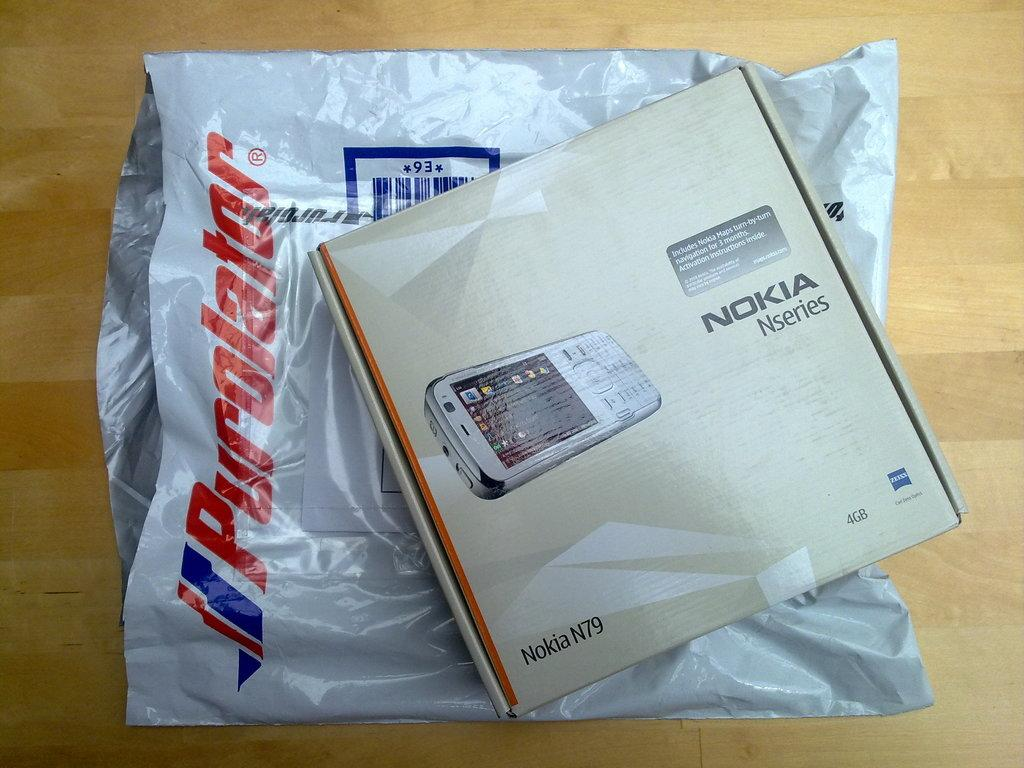<image>
Present a compact description of the photo's key features. The product that was in the bag is a Nokia electronic device. 